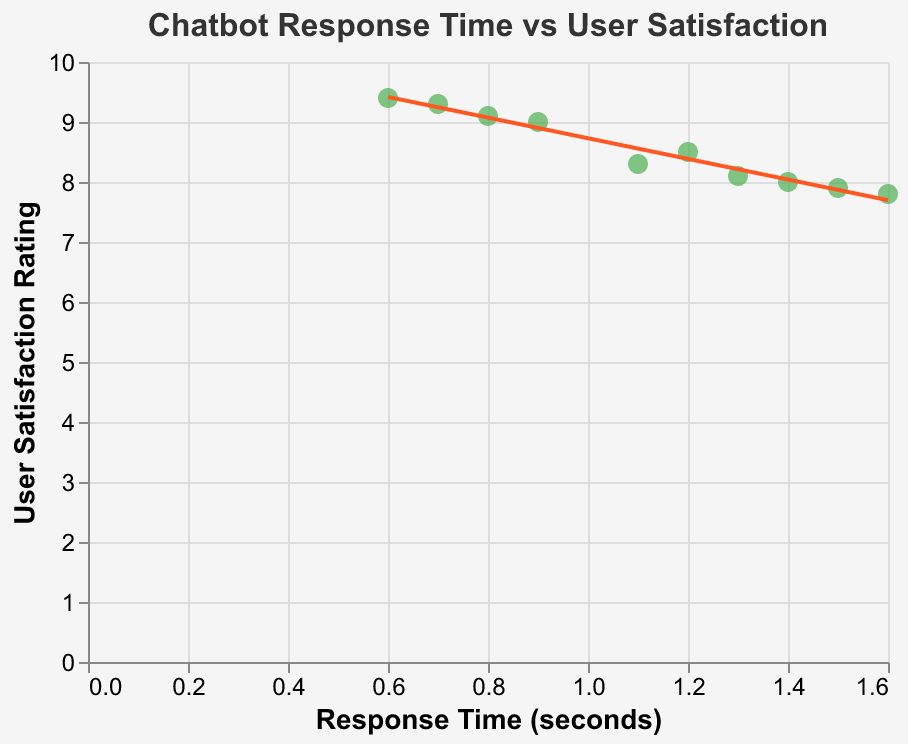What is the title of the figure? The title of the figure is displayed at the top of the plot and uses a font size of 16 in Arial font.
Answer: Chatbot Response Time vs User Satisfaction What are the labels of the x and y axes? The labels of the x and y axes are indicated alongside the respective axes. The x-axis is labeled "Response Time (seconds)" and the y-axis is labeled "User Satisfaction Rating".
Answer: Response Time (seconds) and User Satisfaction Rating How many data points are present in the scatter plot? To find the number of data points, we count the individual points shown in the plot. There are 10 data points.
Answer: 10 What color are the points in the scatter plot? The points in the scatter plot are represented in green color.
Answer: Green What does the trend line in the plot indicate? The trend line indicates the overall relationship between the response time and user satisfaction ratings. Its slope and direction provide information about how these two variables are correlated.
Answer: It indicates a negative correlation between response time and user satisfaction Which data point has the highest user satisfaction rating? To find the data point with the highest user satisfaction rating, we look at the y-axis values of all points. The data point with a response time of 0.6 seconds has the highest user satisfaction rating of 9.4.
Answer: The data point with a response time of 0.6 seconds Compare the user satisfaction rating for response times of 0.8 and 1.5 seconds. Which one is higher? We examine the y-axis values corresponding to response times of 0.8 and 1.5 seconds. The user satisfaction rating at 0.8 seconds is 9.1, and at 1.5 seconds, it is 7.9.
Answer: The rating at 0.8 seconds is higher What is the average user satisfaction rating for response times less than 1.0 second? To find the average, first identify the user satisfaction ratings for response times less than 1.0 second: 9.1, 9.4, and 9.3. Calculate the sum: 9.1 + 9.4 + 9.3 = 27.8, then divide by the number of points, which is 3.
Answer: 9.27 How does user satisfaction change with increasing response time? To understand how user satisfaction changes with increasing response time, observe the overall trend indicated by the trend line. The trend line suggests that user satisfaction decreases as response time increases.
Answer: Satisfaction decreases What is the lowest user satisfaction rating on the plot and what is its corresponding response time? To find the lowest user satisfaction rating, observe the y-axis values. The lowest rating is 7.8, which corresponds to a response time of 1.6 seconds.
Answer: 7.8 at 1.6 seconds 